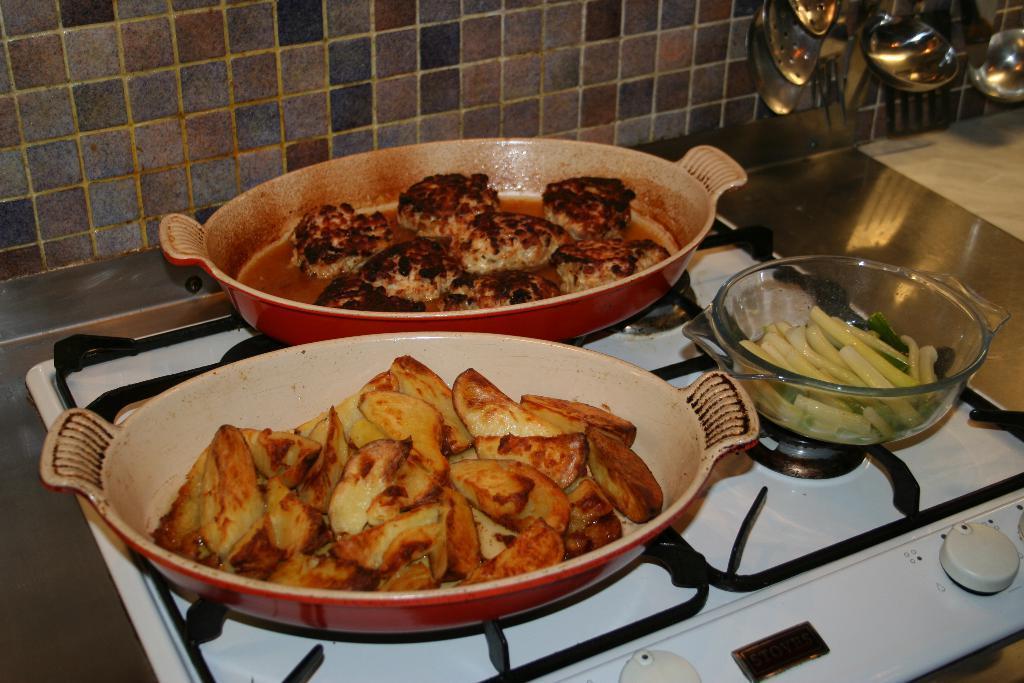How would you summarize this image in a sentence or two? This picture shows food in the trays and we see some food in the bowl on the gas stove and we see few serving spoons. 